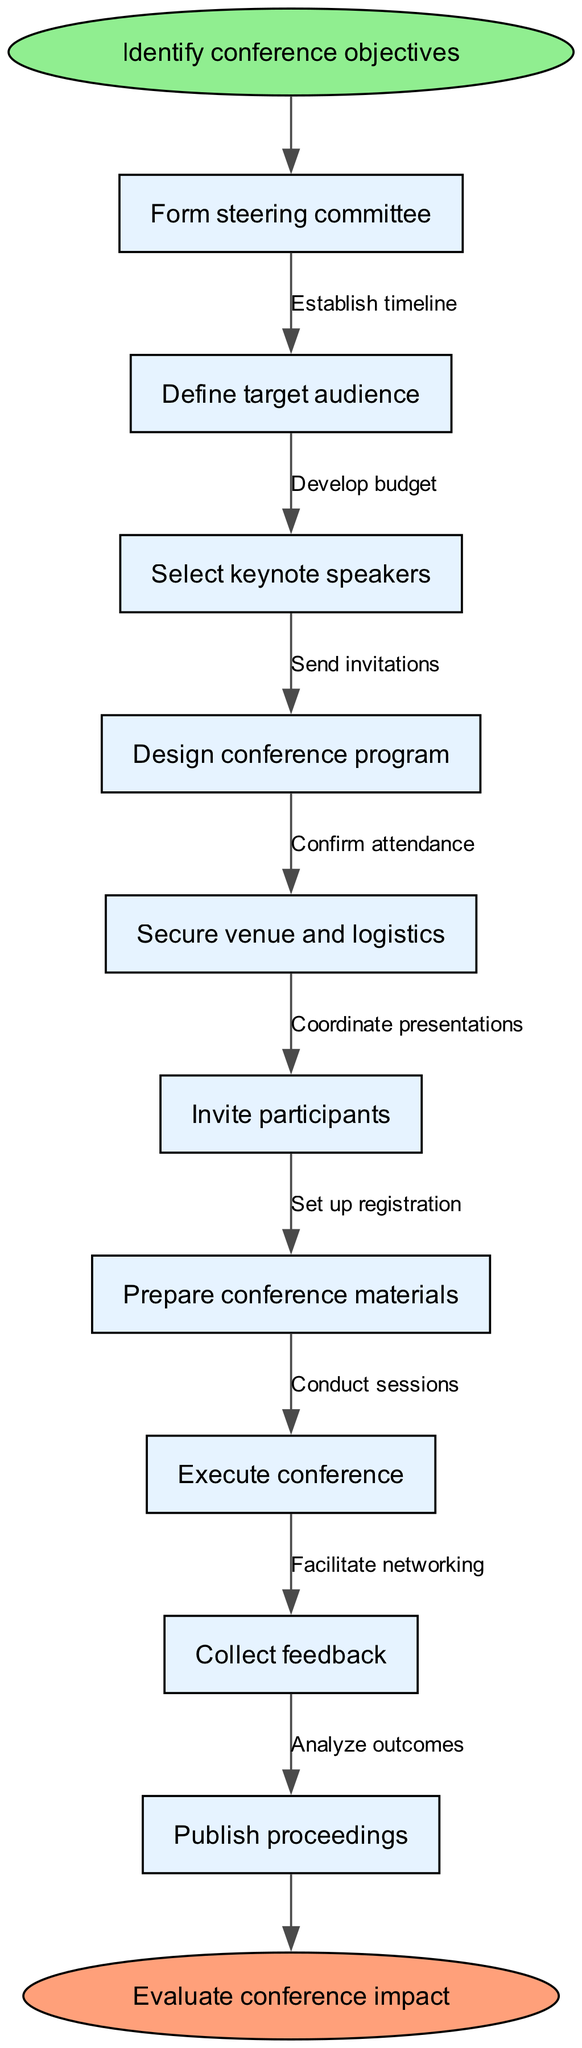What is the first node in the diagram? The first node, which follows the start node, is "Form steering committee". It’s the initial action in organizing the conference, directly following the identification of objectives.
Answer: Form steering committee How many nodes are in the diagram? By counting the nodes, which include the start node, the end node, and the main process nodes, there are a total of 10 nodes in the diagram.
Answer: 10 What follows the node "Define target audience"? The node that follows "Define target audience" is "Select keynote speakers". This indicates a specific sequence in the planning stages for the conference.
Answer: Select keynote speakers What is the last node before the end node? The last node before the end node is "Publish proceedings". This shows the final step in the process before concluding with the evaluation of the conference impact.
Answer: Publish proceedings Which node is connected to "Conduct sessions"? The node connected to "Conduct sessions" is "Execute conference". This indicates that conducting the sessions follows after executing the main parts of the conference.
Answer: Execute conference What is the purpose of the edge labeled "Send invitations"? The edge labeled "Send invitations" shows that this action takes place after "Secure venue and logistics", connecting it to "Invite participants". This signifies the sequence of tasks in the preparation process.
Answer: Invite participants Which node has the edge labeled "Analyze outcomes"? The node that has the edge labeled "Analyze outcomes" is "Collect feedback". This indicates that after receiving feedback, outcomes will be analyzed as part of the conference evaluation.
Answer: Collect feedback How many edges are in the diagram? The edges represent the connections between nodes. Counting the edges, we find there are 9 edges in total within the flow chart.
Answer: 9 What is the final action in the flow of the diagram? The final action in the flow of the diagram is "Evaluate conference impact". This indicates the concluding step of the entire process outlined in the diagram.
Answer: Evaluate conference impact 